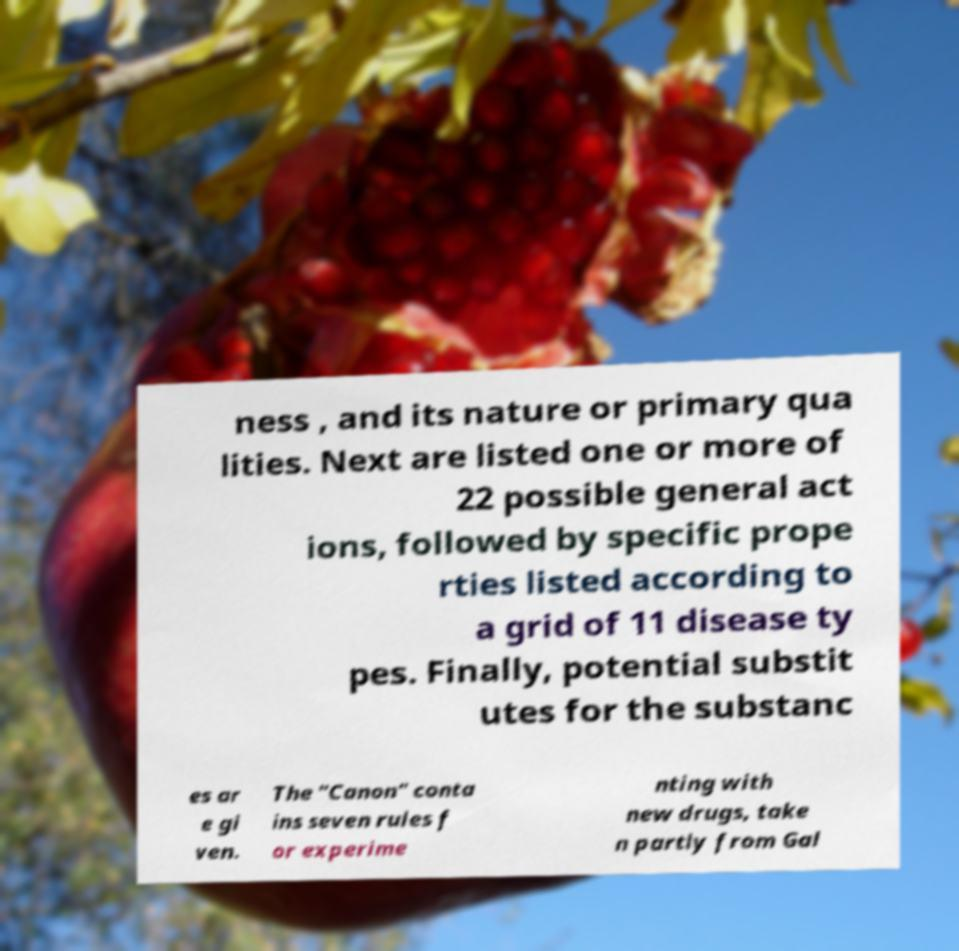There's text embedded in this image that I need extracted. Can you transcribe it verbatim? ness , and its nature or primary qua lities. Next are listed one or more of 22 possible general act ions, followed by specific prope rties listed according to a grid of 11 disease ty pes. Finally, potential substit utes for the substanc es ar e gi ven. The "Canon" conta ins seven rules f or experime nting with new drugs, take n partly from Gal 